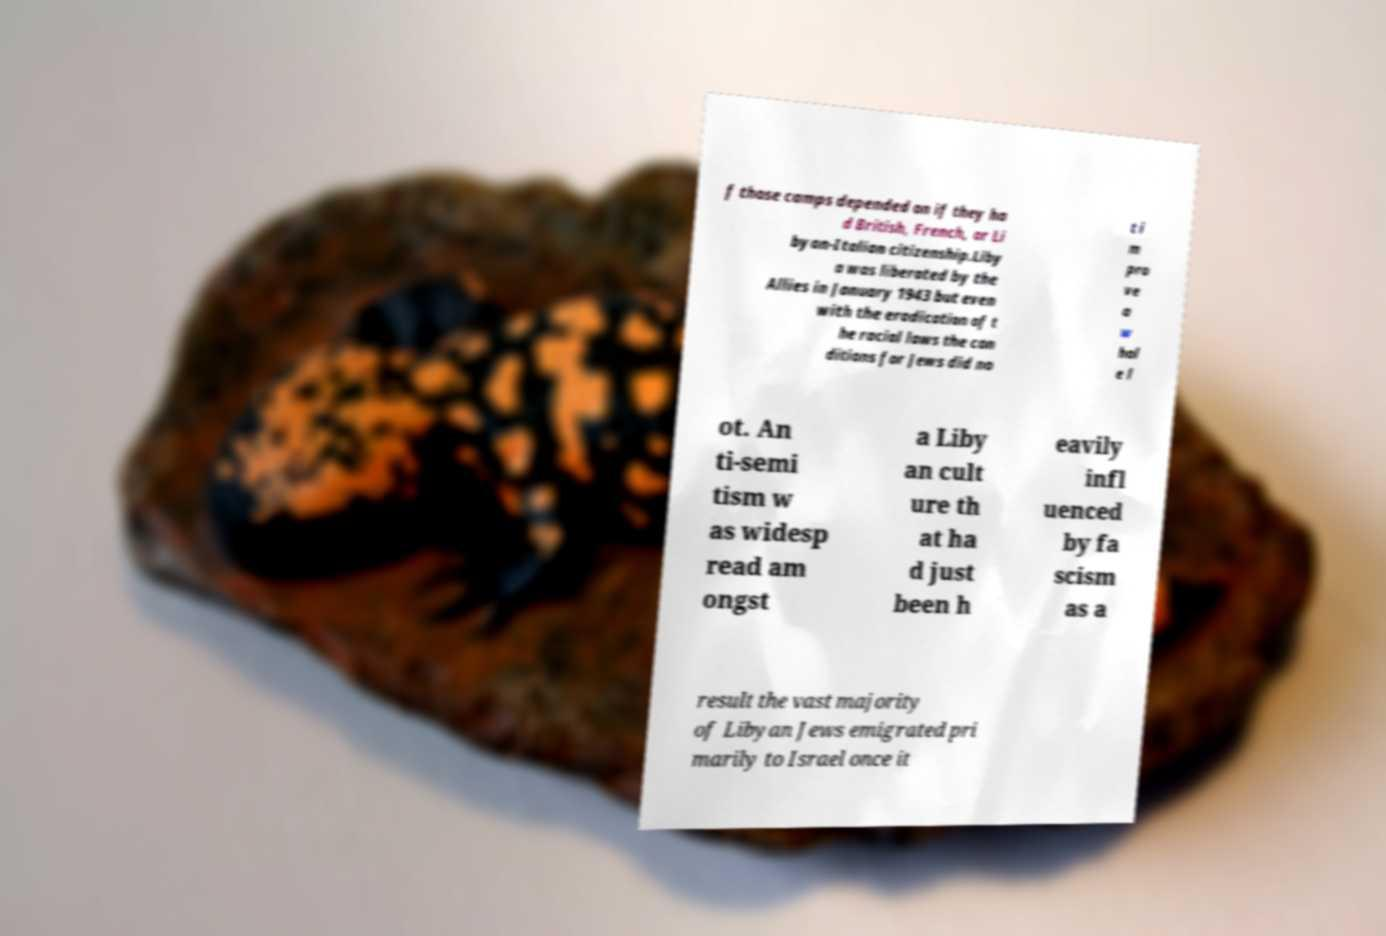Could you assist in decoding the text presented in this image and type it out clearly? f those camps depended on if they ha d British, French, or Li byan-Italian citizenship.Liby a was liberated by the Allies in January 1943 but even with the eradication of t he racial laws the con ditions for Jews did no t i m pro ve a w hol e l ot. An ti-semi tism w as widesp read am ongst a Liby an cult ure th at ha d just been h eavily infl uenced by fa scism as a result the vast majority of Libyan Jews emigrated pri marily to Israel once it 